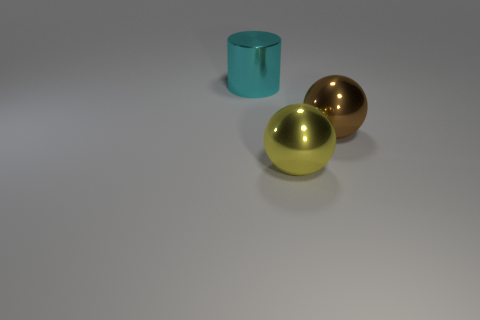Is there any other thing that has the same shape as the brown object? Yes, the golden object to the right of the brown one is also spherical, reflecting the same general shape characteristics as the brown object, but with a different color and surface finish. 